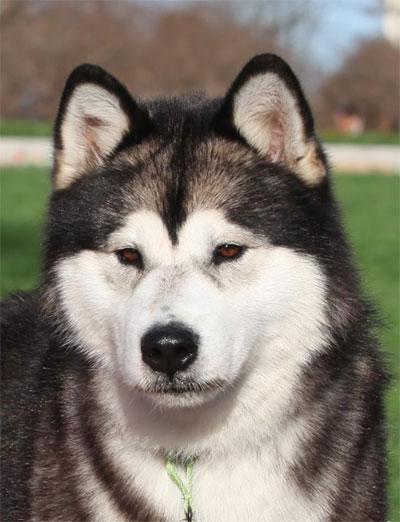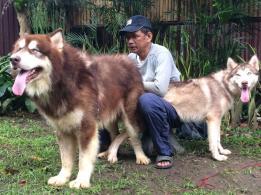The first image is the image on the left, the second image is the image on the right. Assess this claim about the two images: "The right image contains one human interacting with at least one dog.". Correct or not? Answer yes or no. Yes. The first image is the image on the left, the second image is the image on the right. Evaluate the accuracy of this statement regarding the images: "The combined images include at least two husky dogs, with at least one black-and-white, and one standing with tongue out and a man kneeling behind it.". Is it true? Answer yes or no. Yes. 